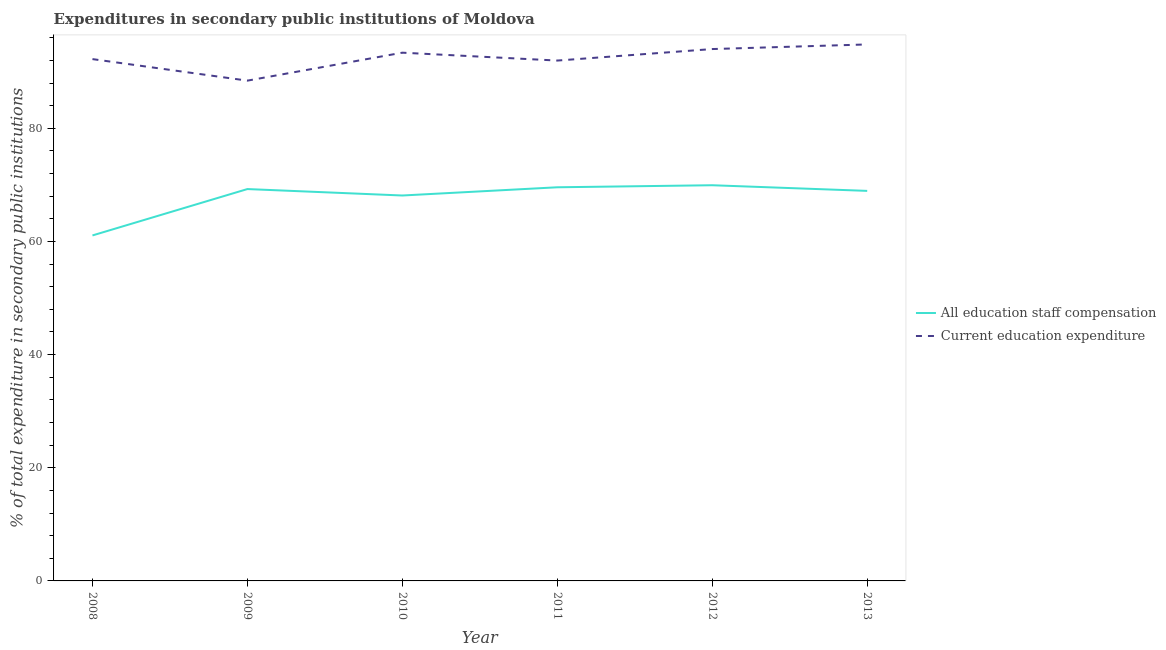How many different coloured lines are there?
Give a very brief answer. 2. Does the line corresponding to expenditure in education intersect with the line corresponding to expenditure in staff compensation?
Your answer should be compact. No. Is the number of lines equal to the number of legend labels?
Give a very brief answer. Yes. What is the expenditure in staff compensation in 2010?
Your answer should be compact. 68.13. Across all years, what is the maximum expenditure in education?
Your answer should be compact. 94.83. Across all years, what is the minimum expenditure in staff compensation?
Provide a succinct answer. 61.07. In which year was the expenditure in education maximum?
Provide a short and direct response. 2013. In which year was the expenditure in education minimum?
Provide a succinct answer. 2009. What is the total expenditure in education in the graph?
Your answer should be very brief. 554.86. What is the difference between the expenditure in staff compensation in 2010 and that in 2013?
Make the answer very short. -0.82. What is the difference between the expenditure in education in 2013 and the expenditure in staff compensation in 2009?
Make the answer very short. 25.57. What is the average expenditure in staff compensation per year?
Your answer should be compact. 67.82. In the year 2011, what is the difference between the expenditure in education and expenditure in staff compensation?
Make the answer very short. 22.4. In how many years, is the expenditure in staff compensation greater than 28 %?
Your answer should be compact. 6. What is the ratio of the expenditure in staff compensation in 2011 to that in 2012?
Your answer should be compact. 0.99. Is the expenditure in staff compensation in 2009 less than that in 2010?
Give a very brief answer. No. What is the difference between the highest and the second highest expenditure in staff compensation?
Provide a short and direct response. 0.36. What is the difference between the highest and the lowest expenditure in education?
Your answer should be compact. 6.4. Does the expenditure in staff compensation monotonically increase over the years?
Your response must be concise. No. Is the expenditure in staff compensation strictly less than the expenditure in education over the years?
Offer a terse response. Yes. How many lines are there?
Provide a succinct answer. 2. Are the values on the major ticks of Y-axis written in scientific E-notation?
Provide a short and direct response. No. How many legend labels are there?
Your answer should be compact. 2. What is the title of the graph?
Keep it short and to the point. Expenditures in secondary public institutions of Moldova. What is the label or title of the Y-axis?
Keep it short and to the point. % of total expenditure in secondary public institutions. What is the % of total expenditure in secondary public institutions in All education staff compensation in 2008?
Give a very brief answer. 61.07. What is the % of total expenditure in secondary public institutions in Current education expenditure in 2008?
Provide a succinct answer. 92.24. What is the % of total expenditure in secondary public institutions in All education staff compensation in 2009?
Ensure brevity in your answer.  69.27. What is the % of total expenditure in secondary public institutions in Current education expenditure in 2009?
Make the answer very short. 88.43. What is the % of total expenditure in secondary public institutions in All education staff compensation in 2010?
Make the answer very short. 68.13. What is the % of total expenditure in secondary public institutions of Current education expenditure in 2010?
Give a very brief answer. 93.37. What is the % of total expenditure in secondary public institutions in All education staff compensation in 2011?
Keep it short and to the point. 69.58. What is the % of total expenditure in secondary public institutions in Current education expenditure in 2011?
Provide a succinct answer. 91.98. What is the % of total expenditure in secondary public institutions in All education staff compensation in 2012?
Ensure brevity in your answer.  69.94. What is the % of total expenditure in secondary public institutions in Current education expenditure in 2012?
Offer a terse response. 94.01. What is the % of total expenditure in secondary public institutions of All education staff compensation in 2013?
Give a very brief answer. 68.94. What is the % of total expenditure in secondary public institutions of Current education expenditure in 2013?
Offer a very short reply. 94.83. Across all years, what is the maximum % of total expenditure in secondary public institutions of All education staff compensation?
Provide a short and direct response. 69.94. Across all years, what is the maximum % of total expenditure in secondary public institutions of Current education expenditure?
Offer a terse response. 94.83. Across all years, what is the minimum % of total expenditure in secondary public institutions of All education staff compensation?
Offer a very short reply. 61.07. Across all years, what is the minimum % of total expenditure in secondary public institutions in Current education expenditure?
Give a very brief answer. 88.43. What is the total % of total expenditure in secondary public institutions of All education staff compensation in the graph?
Keep it short and to the point. 406.93. What is the total % of total expenditure in secondary public institutions in Current education expenditure in the graph?
Make the answer very short. 554.86. What is the difference between the % of total expenditure in secondary public institutions of All education staff compensation in 2008 and that in 2009?
Provide a short and direct response. -8.2. What is the difference between the % of total expenditure in secondary public institutions in Current education expenditure in 2008 and that in 2009?
Provide a succinct answer. 3.81. What is the difference between the % of total expenditure in secondary public institutions of All education staff compensation in 2008 and that in 2010?
Your answer should be compact. -7.06. What is the difference between the % of total expenditure in secondary public institutions in Current education expenditure in 2008 and that in 2010?
Make the answer very short. -1.14. What is the difference between the % of total expenditure in secondary public institutions in All education staff compensation in 2008 and that in 2011?
Your answer should be compact. -8.51. What is the difference between the % of total expenditure in secondary public institutions of Current education expenditure in 2008 and that in 2011?
Your response must be concise. 0.26. What is the difference between the % of total expenditure in secondary public institutions of All education staff compensation in 2008 and that in 2012?
Your answer should be very brief. -8.87. What is the difference between the % of total expenditure in secondary public institutions of Current education expenditure in 2008 and that in 2012?
Your answer should be very brief. -1.78. What is the difference between the % of total expenditure in secondary public institutions in All education staff compensation in 2008 and that in 2013?
Ensure brevity in your answer.  -7.88. What is the difference between the % of total expenditure in secondary public institutions in Current education expenditure in 2008 and that in 2013?
Your answer should be compact. -2.59. What is the difference between the % of total expenditure in secondary public institutions of All education staff compensation in 2009 and that in 2010?
Your response must be concise. 1.14. What is the difference between the % of total expenditure in secondary public institutions of Current education expenditure in 2009 and that in 2010?
Offer a terse response. -4.94. What is the difference between the % of total expenditure in secondary public institutions of All education staff compensation in 2009 and that in 2011?
Offer a terse response. -0.31. What is the difference between the % of total expenditure in secondary public institutions in Current education expenditure in 2009 and that in 2011?
Ensure brevity in your answer.  -3.55. What is the difference between the % of total expenditure in secondary public institutions in All education staff compensation in 2009 and that in 2012?
Give a very brief answer. -0.68. What is the difference between the % of total expenditure in secondary public institutions in Current education expenditure in 2009 and that in 2012?
Your answer should be very brief. -5.58. What is the difference between the % of total expenditure in secondary public institutions in All education staff compensation in 2009 and that in 2013?
Ensure brevity in your answer.  0.32. What is the difference between the % of total expenditure in secondary public institutions in Current education expenditure in 2009 and that in 2013?
Offer a terse response. -6.4. What is the difference between the % of total expenditure in secondary public institutions in All education staff compensation in 2010 and that in 2011?
Your answer should be very brief. -1.45. What is the difference between the % of total expenditure in secondary public institutions of Current education expenditure in 2010 and that in 2011?
Provide a succinct answer. 1.39. What is the difference between the % of total expenditure in secondary public institutions of All education staff compensation in 2010 and that in 2012?
Your answer should be compact. -1.81. What is the difference between the % of total expenditure in secondary public institutions in Current education expenditure in 2010 and that in 2012?
Ensure brevity in your answer.  -0.64. What is the difference between the % of total expenditure in secondary public institutions of All education staff compensation in 2010 and that in 2013?
Ensure brevity in your answer.  -0.82. What is the difference between the % of total expenditure in secondary public institutions in Current education expenditure in 2010 and that in 2013?
Make the answer very short. -1.46. What is the difference between the % of total expenditure in secondary public institutions in All education staff compensation in 2011 and that in 2012?
Make the answer very short. -0.36. What is the difference between the % of total expenditure in secondary public institutions of Current education expenditure in 2011 and that in 2012?
Your response must be concise. -2.04. What is the difference between the % of total expenditure in secondary public institutions of All education staff compensation in 2011 and that in 2013?
Offer a very short reply. 0.64. What is the difference between the % of total expenditure in secondary public institutions in Current education expenditure in 2011 and that in 2013?
Your response must be concise. -2.85. What is the difference between the % of total expenditure in secondary public institutions of Current education expenditure in 2012 and that in 2013?
Ensure brevity in your answer.  -0.82. What is the difference between the % of total expenditure in secondary public institutions of All education staff compensation in 2008 and the % of total expenditure in secondary public institutions of Current education expenditure in 2009?
Ensure brevity in your answer.  -27.36. What is the difference between the % of total expenditure in secondary public institutions of All education staff compensation in 2008 and the % of total expenditure in secondary public institutions of Current education expenditure in 2010?
Make the answer very short. -32.3. What is the difference between the % of total expenditure in secondary public institutions of All education staff compensation in 2008 and the % of total expenditure in secondary public institutions of Current education expenditure in 2011?
Provide a short and direct response. -30.91. What is the difference between the % of total expenditure in secondary public institutions in All education staff compensation in 2008 and the % of total expenditure in secondary public institutions in Current education expenditure in 2012?
Your answer should be compact. -32.95. What is the difference between the % of total expenditure in secondary public institutions of All education staff compensation in 2008 and the % of total expenditure in secondary public institutions of Current education expenditure in 2013?
Your answer should be compact. -33.76. What is the difference between the % of total expenditure in secondary public institutions in All education staff compensation in 2009 and the % of total expenditure in secondary public institutions in Current education expenditure in 2010?
Your answer should be compact. -24.11. What is the difference between the % of total expenditure in secondary public institutions in All education staff compensation in 2009 and the % of total expenditure in secondary public institutions in Current education expenditure in 2011?
Your response must be concise. -22.71. What is the difference between the % of total expenditure in secondary public institutions in All education staff compensation in 2009 and the % of total expenditure in secondary public institutions in Current education expenditure in 2012?
Your response must be concise. -24.75. What is the difference between the % of total expenditure in secondary public institutions of All education staff compensation in 2009 and the % of total expenditure in secondary public institutions of Current education expenditure in 2013?
Provide a succinct answer. -25.57. What is the difference between the % of total expenditure in secondary public institutions of All education staff compensation in 2010 and the % of total expenditure in secondary public institutions of Current education expenditure in 2011?
Provide a succinct answer. -23.85. What is the difference between the % of total expenditure in secondary public institutions in All education staff compensation in 2010 and the % of total expenditure in secondary public institutions in Current education expenditure in 2012?
Give a very brief answer. -25.89. What is the difference between the % of total expenditure in secondary public institutions of All education staff compensation in 2010 and the % of total expenditure in secondary public institutions of Current education expenditure in 2013?
Your answer should be compact. -26.7. What is the difference between the % of total expenditure in secondary public institutions in All education staff compensation in 2011 and the % of total expenditure in secondary public institutions in Current education expenditure in 2012?
Your answer should be compact. -24.43. What is the difference between the % of total expenditure in secondary public institutions in All education staff compensation in 2011 and the % of total expenditure in secondary public institutions in Current education expenditure in 2013?
Your response must be concise. -25.25. What is the difference between the % of total expenditure in secondary public institutions of All education staff compensation in 2012 and the % of total expenditure in secondary public institutions of Current education expenditure in 2013?
Keep it short and to the point. -24.89. What is the average % of total expenditure in secondary public institutions of All education staff compensation per year?
Your answer should be compact. 67.82. What is the average % of total expenditure in secondary public institutions of Current education expenditure per year?
Provide a short and direct response. 92.48. In the year 2008, what is the difference between the % of total expenditure in secondary public institutions in All education staff compensation and % of total expenditure in secondary public institutions in Current education expenditure?
Ensure brevity in your answer.  -31.17. In the year 2009, what is the difference between the % of total expenditure in secondary public institutions of All education staff compensation and % of total expenditure in secondary public institutions of Current education expenditure?
Offer a terse response. -19.17. In the year 2010, what is the difference between the % of total expenditure in secondary public institutions of All education staff compensation and % of total expenditure in secondary public institutions of Current education expenditure?
Ensure brevity in your answer.  -25.24. In the year 2011, what is the difference between the % of total expenditure in secondary public institutions of All education staff compensation and % of total expenditure in secondary public institutions of Current education expenditure?
Your answer should be compact. -22.4. In the year 2012, what is the difference between the % of total expenditure in secondary public institutions of All education staff compensation and % of total expenditure in secondary public institutions of Current education expenditure?
Offer a very short reply. -24.07. In the year 2013, what is the difference between the % of total expenditure in secondary public institutions in All education staff compensation and % of total expenditure in secondary public institutions in Current education expenditure?
Provide a short and direct response. -25.89. What is the ratio of the % of total expenditure in secondary public institutions in All education staff compensation in 2008 to that in 2009?
Your response must be concise. 0.88. What is the ratio of the % of total expenditure in secondary public institutions in Current education expenditure in 2008 to that in 2009?
Your answer should be compact. 1.04. What is the ratio of the % of total expenditure in secondary public institutions in All education staff compensation in 2008 to that in 2010?
Provide a succinct answer. 0.9. What is the ratio of the % of total expenditure in secondary public institutions of All education staff compensation in 2008 to that in 2011?
Offer a terse response. 0.88. What is the ratio of the % of total expenditure in secondary public institutions in Current education expenditure in 2008 to that in 2011?
Your response must be concise. 1. What is the ratio of the % of total expenditure in secondary public institutions of All education staff compensation in 2008 to that in 2012?
Keep it short and to the point. 0.87. What is the ratio of the % of total expenditure in secondary public institutions in Current education expenditure in 2008 to that in 2012?
Keep it short and to the point. 0.98. What is the ratio of the % of total expenditure in secondary public institutions of All education staff compensation in 2008 to that in 2013?
Provide a short and direct response. 0.89. What is the ratio of the % of total expenditure in secondary public institutions of Current education expenditure in 2008 to that in 2013?
Give a very brief answer. 0.97. What is the ratio of the % of total expenditure in secondary public institutions in All education staff compensation in 2009 to that in 2010?
Give a very brief answer. 1.02. What is the ratio of the % of total expenditure in secondary public institutions in Current education expenditure in 2009 to that in 2010?
Give a very brief answer. 0.95. What is the ratio of the % of total expenditure in secondary public institutions of Current education expenditure in 2009 to that in 2011?
Your response must be concise. 0.96. What is the ratio of the % of total expenditure in secondary public institutions in All education staff compensation in 2009 to that in 2012?
Keep it short and to the point. 0.99. What is the ratio of the % of total expenditure in secondary public institutions in Current education expenditure in 2009 to that in 2012?
Provide a short and direct response. 0.94. What is the ratio of the % of total expenditure in secondary public institutions of Current education expenditure in 2009 to that in 2013?
Provide a short and direct response. 0.93. What is the ratio of the % of total expenditure in secondary public institutions in All education staff compensation in 2010 to that in 2011?
Give a very brief answer. 0.98. What is the ratio of the % of total expenditure in secondary public institutions in Current education expenditure in 2010 to that in 2011?
Provide a short and direct response. 1.02. What is the ratio of the % of total expenditure in secondary public institutions of All education staff compensation in 2010 to that in 2012?
Make the answer very short. 0.97. What is the ratio of the % of total expenditure in secondary public institutions in Current education expenditure in 2010 to that in 2012?
Your answer should be compact. 0.99. What is the ratio of the % of total expenditure in secondary public institutions of Current education expenditure in 2010 to that in 2013?
Give a very brief answer. 0.98. What is the ratio of the % of total expenditure in secondary public institutions of Current education expenditure in 2011 to that in 2012?
Give a very brief answer. 0.98. What is the ratio of the % of total expenditure in secondary public institutions in All education staff compensation in 2011 to that in 2013?
Offer a terse response. 1.01. What is the ratio of the % of total expenditure in secondary public institutions in Current education expenditure in 2011 to that in 2013?
Your response must be concise. 0.97. What is the ratio of the % of total expenditure in secondary public institutions of All education staff compensation in 2012 to that in 2013?
Your response must be concise. 1.01. What is the difference between the highest and the second highest % of total expenditure in secondary public institutions in All education staff compensation?
Your response must be concise. 0.36. What is the difference between the highest and the second highest % of total expenditure in secondary public institutions of Current education expenditure?
Keep it short and to the point. 0.82. What is the difference between the highest and the lowest % of total expenditure in secondary public institutions in All education staff compensation?
Your answer should be compact. 8.87. What is the difference between the highest and the lowest % of total expenditure in secondary public institutions of Current education expenditure?
Keep it short and to the point. 6.4. 